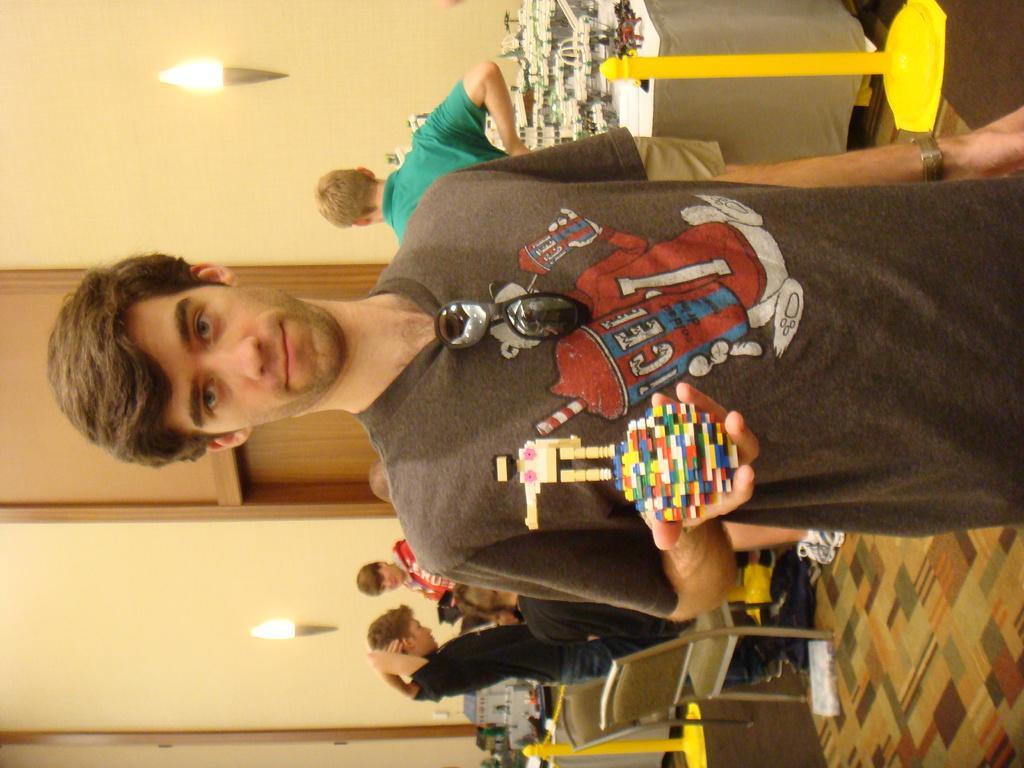Describe this image in one or two sentences. In this image we can see a group of people. One person is sitting on a chair. One person is holding a toy in his hand. In the background, we can see group of toys placed on the table and some poles placed on the ground. In the left side of the image we can see a door and some lights on the wall. 